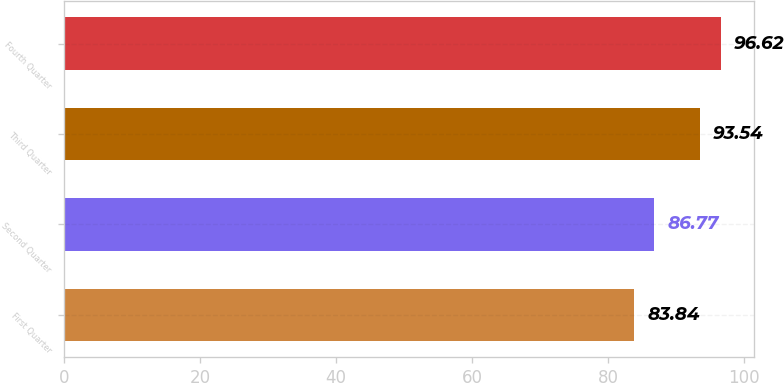Convert chart. <chart><loc_0><loc_0><loc_500><loc_500><bar_chart><fcel>First Quarter<fcel>Second Quarter<fcel>Third Quarter<fcel>Fourth Quarter<nl><fcel>83.84<fcel>86.77<fcel>93.54<fcel>96.62<nl></chart> 